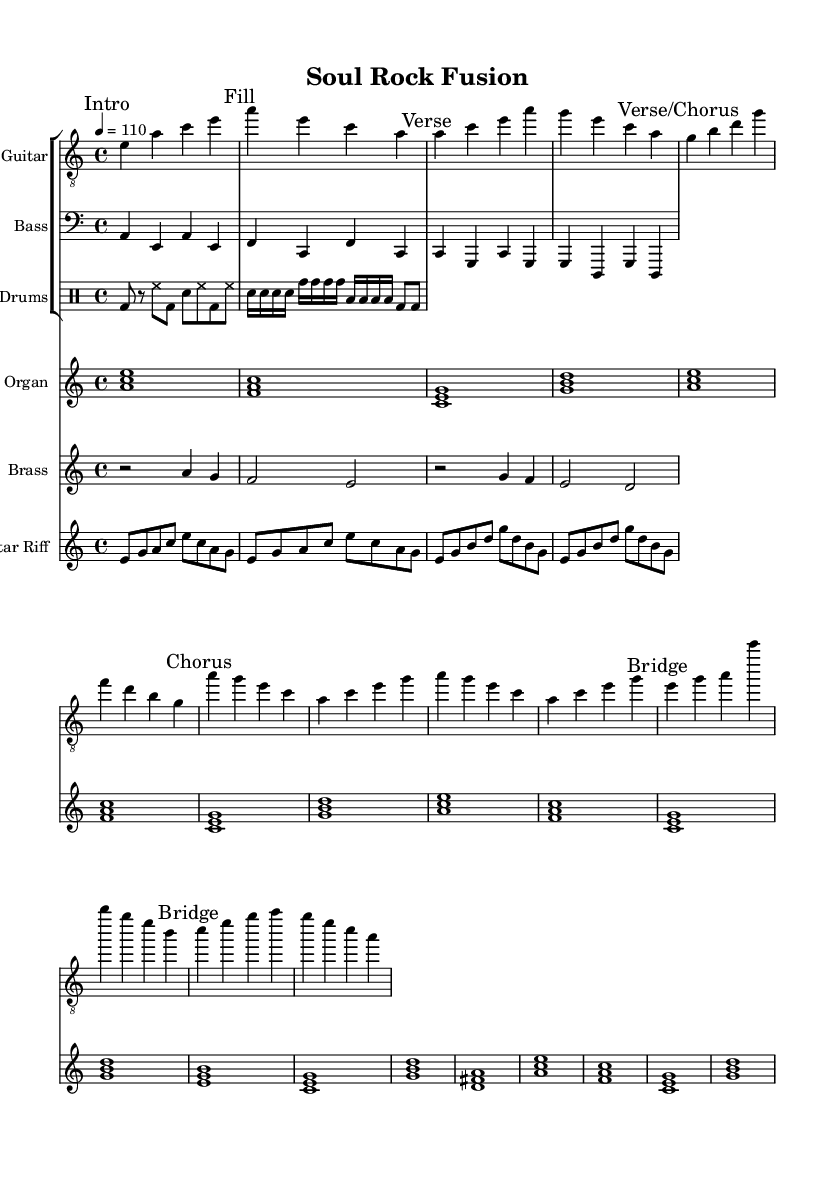What is the key signature of this music? The key signature is A minor, which has no sharps or flats.
Answer: A minor What is the time signature of this music? The time signature is indicated as 4/4, meaning there are four beats in a measure.
Answer: 4/4 What is the tempo marking of this composition? The tempo marking is indicated as quarter note equals 110 beats per minute, showing a moderate pace.
Answer: 110 How many measures are found in the "Chorus" section? To find the number of measures in the "Chorus," we can count the measures in the electric guitar part marked "Chorus," which has two measures.
Answer: 2 Which instrument plays the main riff? The main riff is played on the Electric Guitar as indicated in the score.
Answer: Electric Guitar What does "a:m" signify in the organ chords? "a:m" represents an A minor chord, which is defined by the root note 'a' and its associated minor characteristic.
Answer: A minor What roles do the brass sections play in the piece? The brass section provides accents in the "Chorus Hits," contributing to the overall dynamic structure by adding emphasis during the chorus.
Answer: Accents 